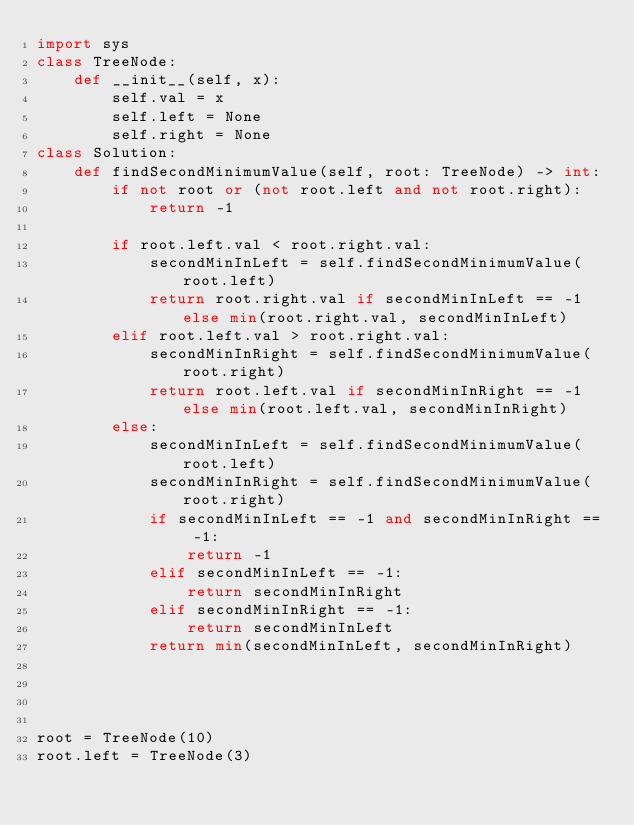Convert code to text. <code><loc_0><loc_0><loc_500><loc_500><_Python_>import sys
class TreeNode:
    def __init__(self, x):
        self.val = x
        self.left = None
        self.right = None
class Solution:    
    def findSecondMinimumValue(self, root: TreeNode) -> int:
        if not root or (not root.left and not root.right):
            return -1
        
        if root.left.val < root.right.val:
            secondMinInLeft = self.findSecondMinimumValue(root.left)
            return root.right.val if secondMinInLeft == -1 else min(root.right.val, secondMinInLeft)
        elif root.left.val > root.right.val:
            secondMinInRight = self.findSecondMinimumValue(root.right)
            return root.left.val if secondMinInRight == -1 else min(root.left.val, secondMinInRight)
        else:
            secondMinInLeft = self.findSecondMinimumValue(root.left)
            secondMinInRight = self.findSecondMinimumValue(root.right)
            if secondMinInLeft == -1 and secondMinInRight == -1:
                return -1
            elif secondMinInLeft == -1:
                return secondMinInRight
            elif secondMinInRight == -1:
                return secondMinInLeft            
            return min(secondMinInLeft, secondMinInRight)
            
            
    

root = TreeNode(10)
root.left = TreeNode(3)</code> 